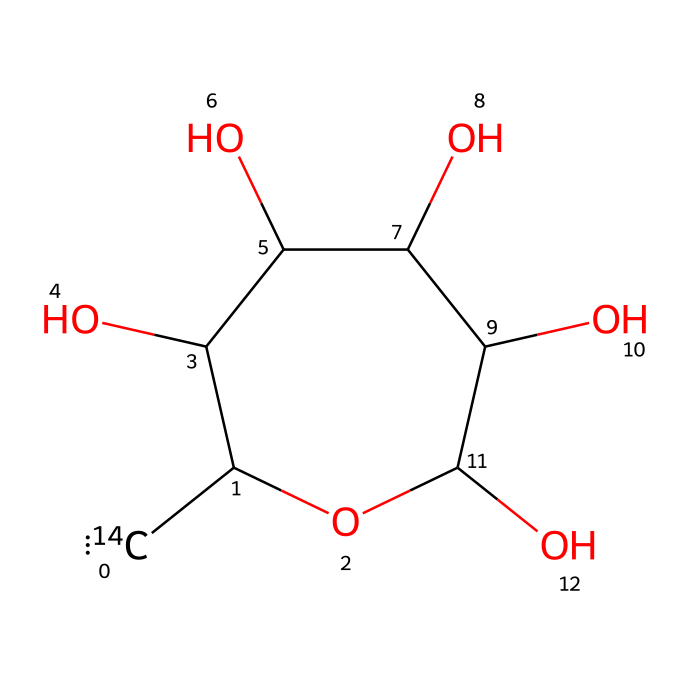What is the molecular formula of carbon-14 labeled glucose? The SMILES representation indicates that the compound contains six carbon atoms, twelve hydrogen atoms, and six oxygen atoms, resulting in the molecular formula C6H12O6.
Answer: C6H12O6 How many hydroxyl groups (-OH) are present in this structure? The chemical structure shows five hydroxyl groups attached to the carbon atoms, indicating a total of five -OH groups in this glucose molecule.
Answer: 5 Which atom in the structure is specifically labeled as carbon-14? The notation “[14C]” before one of the carbon atoms in the SMILES indicates that this particular carbon atom has been substituted with the carbon-14 isotope, which distinguishes it from the other carbons in the glucose molecule.
Answer: 1 What type of carbohydrate is represented by this chemical structure? Given the structure's arrangement of carbon, hydrogen, and oxygen atoms with multiple hydroxyl groups, it can be identified as a monosaccharide, specifically a hexose sugar due to the six carbon atoms.
Answer: monosaccharide How does the presence of carbon-14 affect the applications of this glucose molecule? The incorporation of carbon-14 in glucose allows it to be used as a tracer in various biochemical studies and research applications, particularly in metabolic tracking and carbon dating, due to its radioactive nature.
Answer: tracer What is the significance of the cyclic structure indicated in the SMILES? The presence of "C1" and "C" in the SMILES indicates that the molecule forms a cyclic structure (pyranose), which is crucial for glucose's biological activity and how it interacts with enzymes and other molecules.
Answer: pyranose 